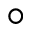<formula> <loc_0><loc_0><loc_500><loc_500>^ { \circ }</formula> 